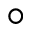<formula> <loc_0><loc_0><loc_500><loc_500>^ { \circ }</formula> 